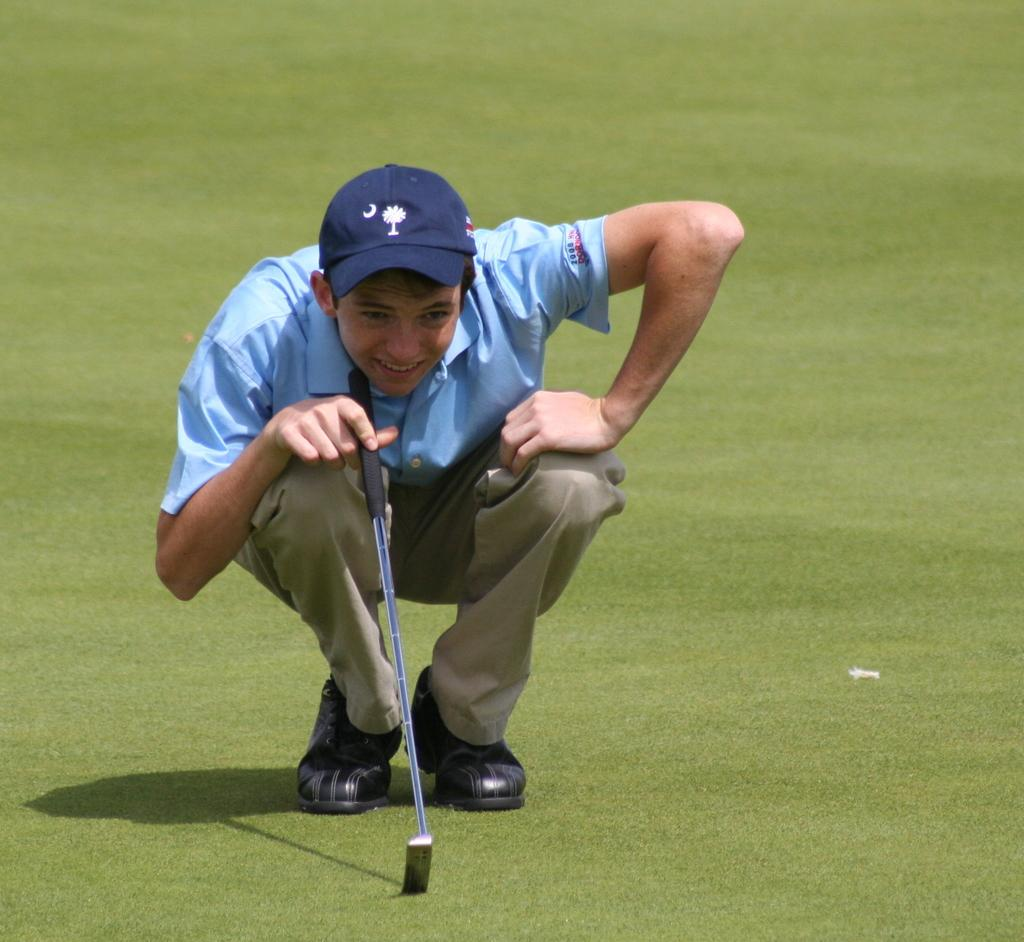Who is present in the image? There is a man in the image. What is the man wearing on his head? The man is wearing a cap. What type of footwear is the man wearing? The man is wearing shoes. What is the man holding in his hand? The man is holding a stick. What can be seen in the background of the image? There is grass visible in the background of the image. What type of rat can be seen climbing the brick wall in the image? There is no rat or brick wall present in the image; it features a man holding a stick with grass in the background. 